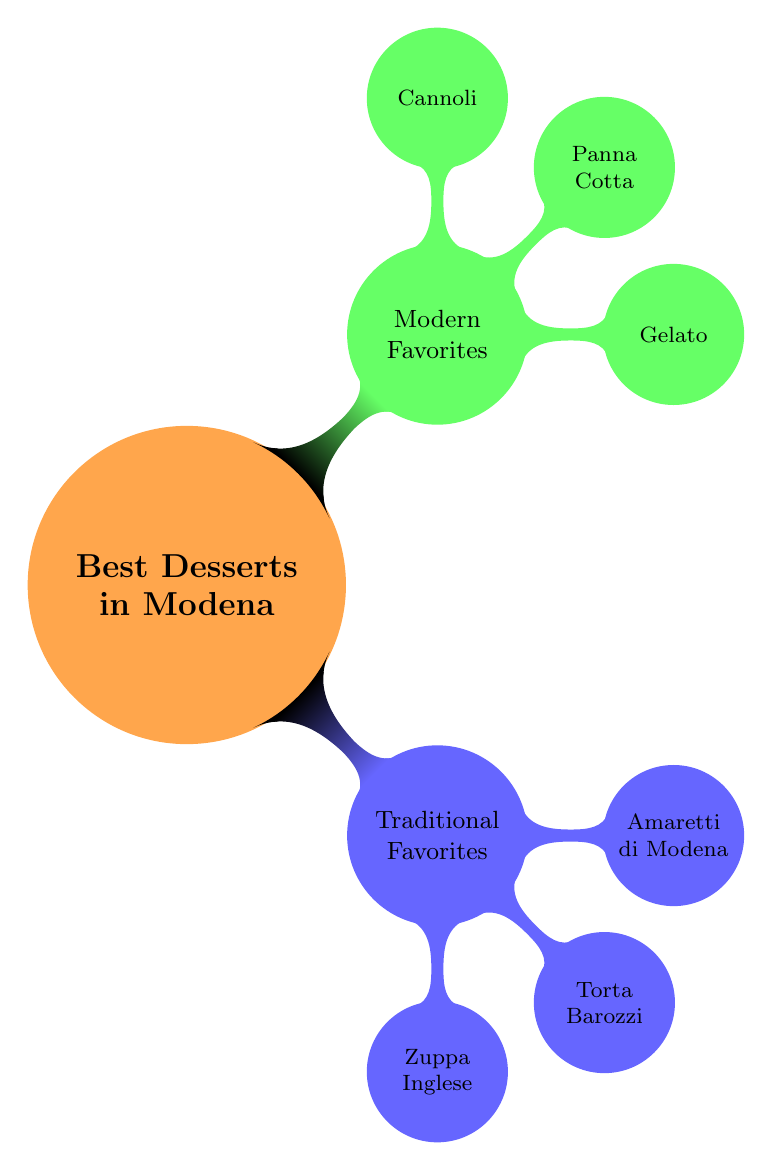What is the main topic of the mind map? The central node of the mind map contains the primary subject, which is "Best Desserts in Modena."
Answer: Best Desserts in Modena How many traditional favorites are listed? The "Traditional Favorites" node has three children nodes that represent specific desserts, indicating there are three traditional favorites listed.
Answer: 3 What dessert is known for its layers? By examining the "Traditional Favorites," the dessert "Zuppa Inglese" is identified as a layered dessert, thus answering the question.
Answer: Zuppa Inglese Which modern dessert is described as traditional Italian ice cream? The "Modern Favorites" section indicates that "Gelato" represents the traditional Italian ice cream among the modern desserts offered.
Answer: Gelato What are the key ingredients of Torta Barozzi? To answer this, one would look at the node for "Torta Barozzi" in the "Traditional Favorites" section, which includes "Chocolate," "Almonds," and "Coffee" as key ingredients.
Answer: Chocolate, Almonds, Coffee Which dessert contains ricotta cheese? Inspecting the "Modern Favorites," the dessert "Cannoli" is noted for containing creamy ricotta cheese, thus providing the answer.
Answer: Cannoli What is a characteristic of Amaretti di Modena? This dessert is described in the "Traditional Favorites" section and is known for its crunchy texture and bittersweet taste, which define its characteristic.
Answer: Crunchy almond cookies How many modern favorites are listed? A careful look at the "Modern Favorites" node shows there are three desserts listed: Gelato, Panna Cotta, and Cannoli. Thus, there are three modern favorites.
Answer: 3 What type of dessert is Panna Cotta? By observing the description of Panna Cotta in the "Modern Favorites," it is identified as a creamy dessert with a custard-like consistency.
Answer: Creamy dessert Which traditional dessert is associated with a liqueur? The "Zuppa Inglese" dessert is explicitly related to Alchermes liqueur in the key ingredients, making it the dessert associated with a liqueur.
Answer: Zuppa Inglese 